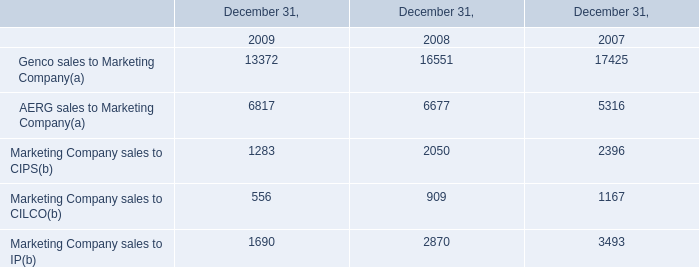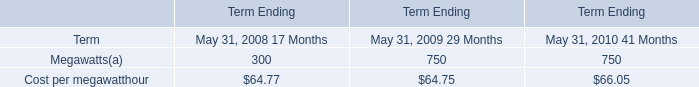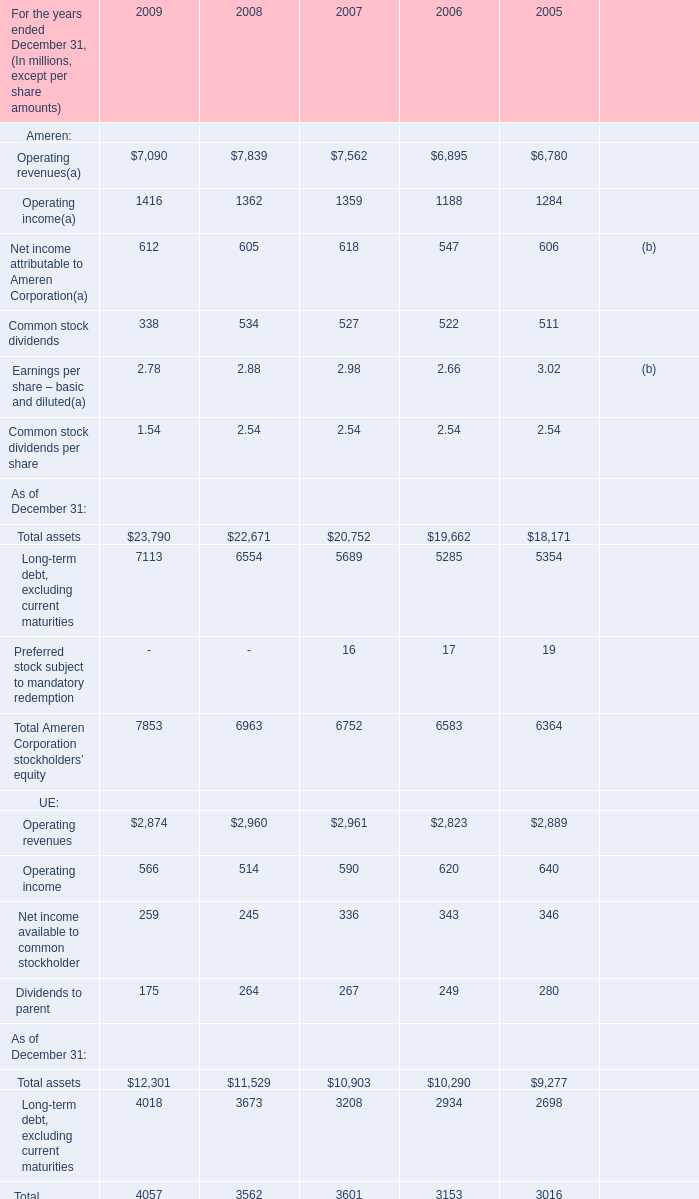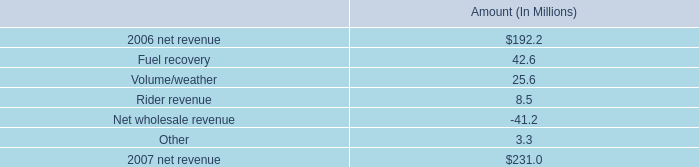What is the average amount of Marketing Company sales to CIPS of December 31, 2007, and Operating income of 2005 ? 
Computations: ((2396.0 + 1284.0) / 2)
Answer: 1840.0. 